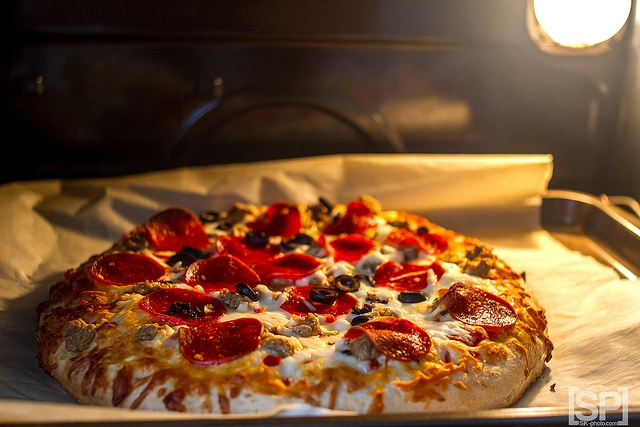Describe the objects in this image and their specific colors. I can see a pizza in black, maroon, and brown tones in this image. 